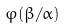Convert formula to latex. <formula><loc_0><loc_0><loc_500><loc_500>\varphi ( \beta / \alpha )</formula> 